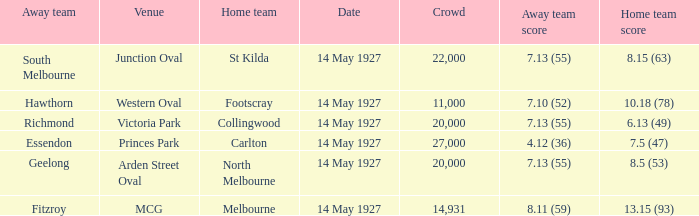On what date does Essendon play as the away team? 14 May 1927. 